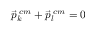Convert formula to latex. <formula><loc_0><loc_0><loc_500><loc_500>\vec { p } _ { k } ^ { \, c m } + \vec { p } _ { l } ^ { \, c m } = 0</formula> 